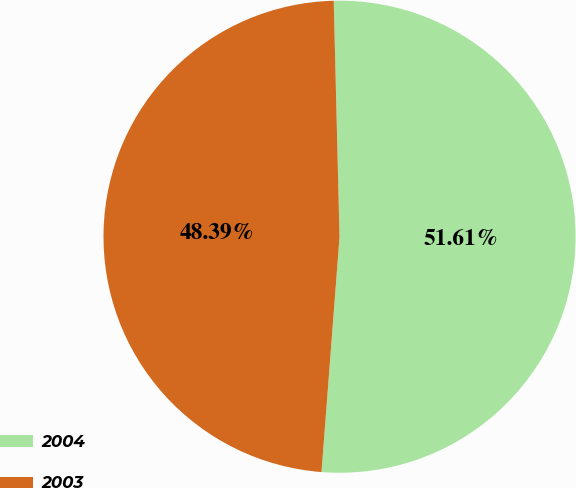Convert chart to OTSL. <chart><loc_0><loc_0><loc_500><loc_500><pie_chart><fcel>2004<fcel>2003<nl><fcel>51.61%<fcel>48.39%<nl></chart> 